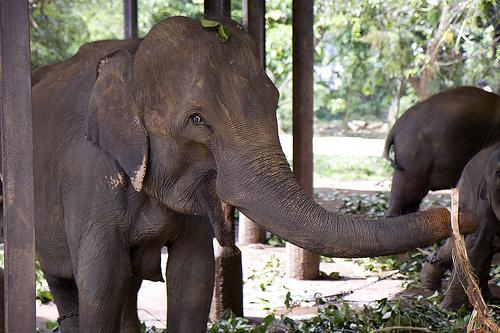Question: how many elephants are seen?
Choices:
A. Three.
B. Four.
C. Five.
D. Six.
Answer with the letter. Answer: A Question: what is in the background?
Choices:
A. Trees.
B. Bushes.
C. Kids.
D. Cars.
Answer with the letter. Answer: A Question: what is on the ground in front of the elephants?
Choices:
A. Dirt.
B. Food.
C. Leaves.
D. A man.
Answer with the letter. Answer: C Question: who is picking up sticks with his trunk?
Choices:
A. The baby elephant.
B. The larger elephant.
C. The middle elephant.
D. The mommy elephant.
Answer with the letter. Answer: B Question: why is the elephant picking up limbs?
Choices:
A. Eating.
B. Making shelter.
C. Having fun.
D. Playing.
Answer with the letter. Answer: A 